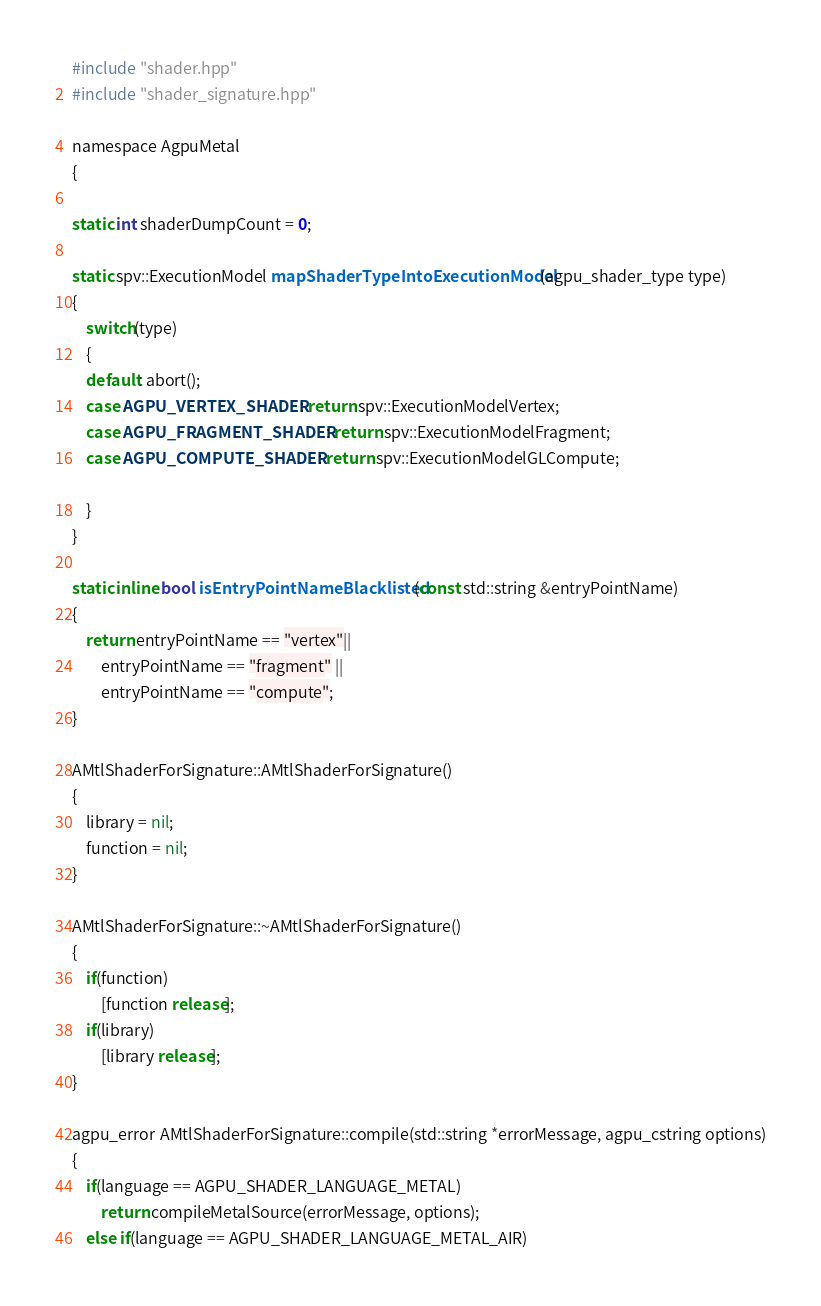Convert code to text. <code><loc_0><loc_0><loc_500><loc_500><_ObjectiveC_>#include "shader.hpp"
#include "shader_signature.hpp"

namespace AgpuMetal
{
    
static int shaderDumpCount = 0;

static spv::ExecutionModel mapShaderTypeIntoExecutionModel(agpu_shader_type type)
{
    switch(type)
    {
    default: abort();
    case AGPU_VERTEX_SHADER: return spv::ExecutionModelVertex;
    case AGPU_FRAGMENT_SHADER: return spv::ExecutionModelFragment;
    case AGPU_COMPUTE_SHADER: return spv::ExecutionModelGLCompute;
    
    }
}

static inline bool isEntryPointNameBlacklisted(const std::string &entryPointName)
{
    return entryPointName == "vertex"|| 
        entryPointName == "fragment" ||
        entryPointName == "compute";
}

AMtlShaderForSignature::AMtlShaderForSignature()
{
    library = nil;
    function = nil;
}

AMtlShaderForSignature::~AMtlShaderForSignature()
{
    if(function)
        [function release];
    if(library)
        [library release];
}

agpu_error AMtlShaderForSignature::compile(std::string *errorMessage, agpu_cstring options)
{
    if(language == AGPU_SHADER_LANGUAGE_METAL)
        return compileMetalSource(errorMessage, options);
    else if(language == AGPU_SHADER_LANGUAGE_METAL_AIR)</code> 